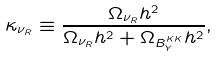<formula> <loc_0><loc_0><loc_500><loc_500>\kappa _ { \nu _ { R } } \equiv \frac { \Omega _ { \nu _ { R } } h ^ { 2 } } { \Omega _ { \nu _ { R } } h ^ { 2 } + \Omega _ { B _ { Y } ^ { K K } } h ^ { 2 } } ,</formula> 